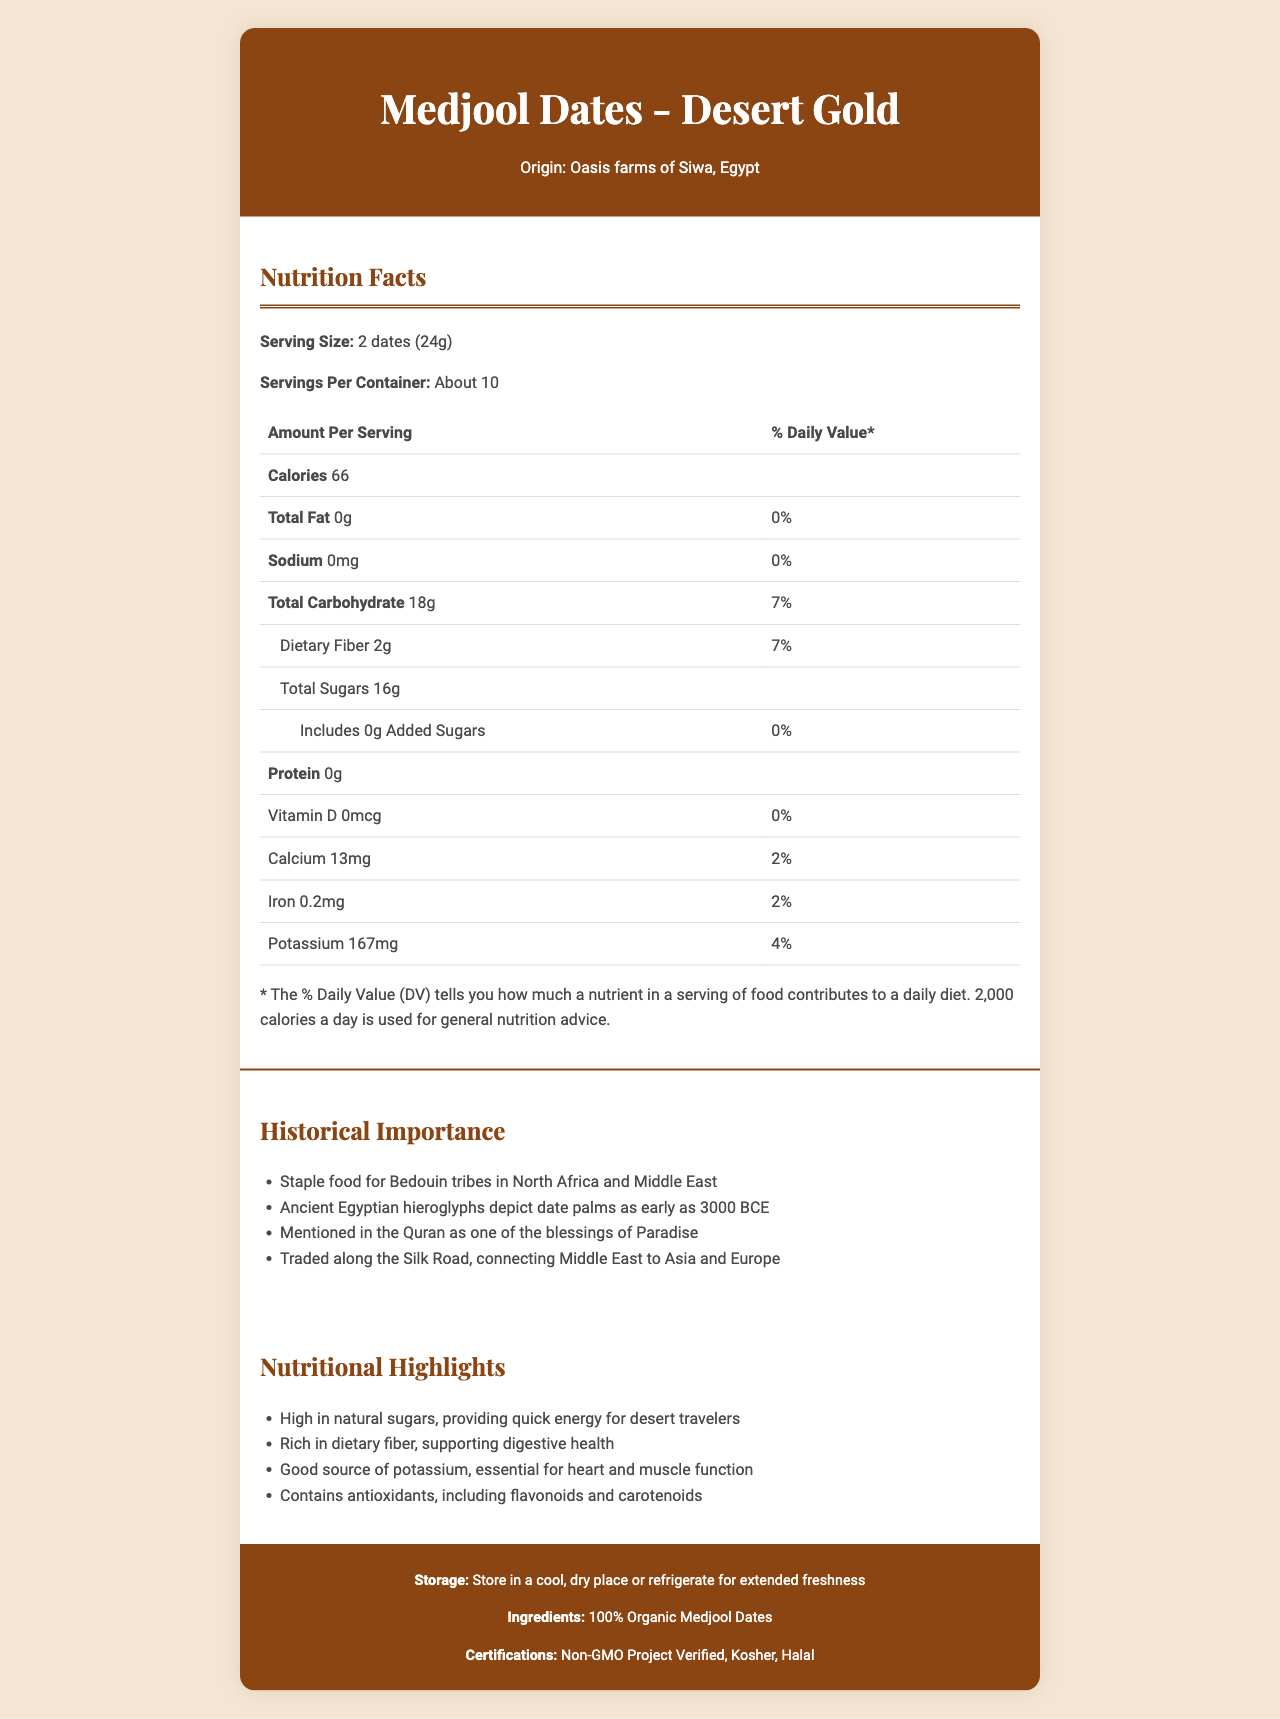what is the serving size for Medjool Dates - Desert Gold? The serving size is explicitly stated as "2 dates (24g)" in the nutrition facts section.
Answer: 2 dates (24g) how many calories are in one serving of Medjool Dates - Desert Gold? The document specifies that there are 66 calories per serving.
Answer: 66 what is the total carbohydrate content in one serving? The total carbohydrate content is listed as 18g per serving in the nutrition facts table.
Answer: 18g does Medjool Dates - Desert Gold contain any added sugars? The nutrition facts label shows that the amount of added sugars is 0g.
Answer: No how much dietary fiber is present in one serving of these dates? The dietary fiber content is listed as 2g per serving in the nutrition facts section.
Answer: 2g what are some of the historical significances of dates mentioned in the document? The historical importance section lists these points as examples of the cultural and historical significance of dates.
Answer: Staple food for Bedouin tribes, depicted in ancient Egyptian hieroglyphs, mentioned in the Quran, traded along the Silk Road what is the origin of Medjool Dates - Desert Gold? The document states that the dates originate from the oasis farms of Siwa, Egypt.
Answer: Oasis farms of Siwa, Egypt which nutrient is provided in the highest amount per serving: calcium, iron, or potassium? A) Calcium B) Iron C) Potassium The amounts listed are 13mg of calcium, 0.2mg of iron, and 167mg of potassium. Potassium is the highest.
Answer: C) Potassium what certification labels do the Medjool Dates - Desert Gold carry? A) Organic, Gluten-Free B) Non-GMO Project Verified, Kosher, Halal C) Fair Trade Certified The certifications section lists Non-GMO Project Verified, Kosher, and Halal.
Answer: B) Non-GMO Project Verified, Kosher, Halal does the document mention if the dates contain protein? The nutrition facts label lists the protein content as 0g.
Answer: Yes summarize the main idea of the document. The document extensively details the nutritional facts, historical significance, and health benefits of Medjool Dates - Desert Gold, while also providing information about their origin and certifications.
Answer: The document provides detailed nutritional information on Medjool Dates - Desert Gold, including serving size, calories, and nutrient content. It also mentions the historical and nutritional importance of dates, their origin, and certifications. were dates depicted in Greek pottery? The document does not provide any information regarding dates being depicted in Greek pottery.
Answer: Not enough information 